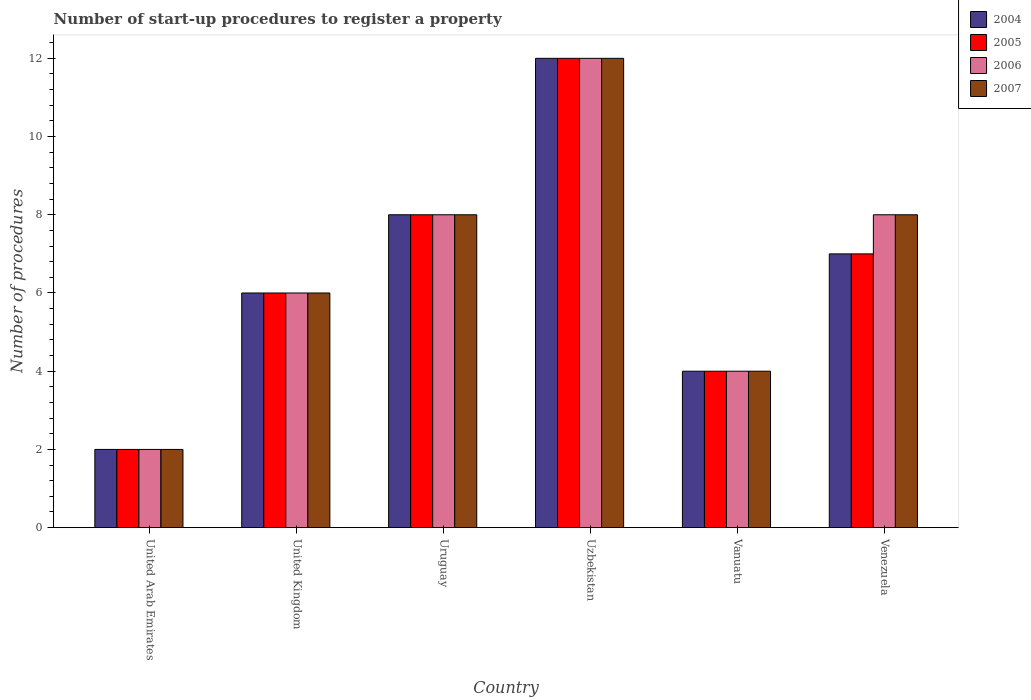How many different coloured bars are there?
Your answer should be compact. 4. Are the number of bars per tick equal to the number of legend labels?
Offer a terse response. Yes. Are the number of bars on each tick of the X-axis equal?
Ensure brevity in your answer.  Yes. What is the label of the 3rd group of bars from the left?
Offer a terse response. Uruguay. In how many cases, is the number of bars for a given country not equal to the number of legend labels?
Make the answer very short. 0. In which country was the number of procedures required to register a property in 2006 maximum?
Offer a terse response. Uzbekistan. In which country was the number of procedures required to register a property in 2006 minimum?
Ensure brevity in your answer.  United Arab Emirates. What is the difference between the number of procedures required to register a property in 2007 in Uzbekistan and that in Vanuatu?
Offer a terse response. 8. Is the number of procedures required to register a property in 2007 in United Arab Emirates less than that in Uzbekistan?
Your response must be concise. Yes. What is the difference between the highest and the second highest number of procedures required to register a property in 2007?
Give a very brief answer. -4. What is the difference between the highest and the lowest number of procedures required to register a property in 2004?
Provide a succinct answer. 10. Is it the case that in every country, the sum of the number of procedures required to register a property in 2005 and number of procedures required to register a property in 2007 is greater than the sum of number of procedures required to register a property in 2004 and number of procedures required to register a property in 2006?
Ensure brevity in your answer.  No. Is it the case that in every country, the sum of the number of procedures required to register a property in 2007 and number of procedures required to register a property in 2004 is greater than the number of procedures required to register a property in 2006?
Keep it short and to the point. Yes. Are the values on the major ticks of Y-axis written in scientific E-notation?
Keep it short and to the point. No. Does the graph contain grids?
Offer a terse response. No. How many legend labels are there?
Ensure brevity in your answer.  4. How are the legend labels stacked?
Ensure brevity in your answer.  Vertical. What is the title of the graph?
Provide a short and direct response. Number of start-up procedures to register a property. What is the label or title of the X-axis?
Offer a very short reply. Country. What is the label or title of the Y-axis?
Provide a succinct answer. Number of procedures. What is the Number of procedures of 2006 in United Arab Emirates?
Offer a terse response. 2. What is the Number of procedures in 2005 in United Kingdom?
Your response must be concise. 6. What is the Number of procedures in 2004 in Uruguay?
Offer a very short reply. 8. What is the Number of procedures in 2006 in Uruguay?
Your response must be concise. 8. What is the Number of procedures of 2007 in Uruguay?
Make the answer very short. 8. What is the Number of procedures of 2004 in Uzbekistan?
Make the answer very short. 12. What is the Number of procedures in 2005 in Uzbekistan?
Your answer should be very brief. 12. What is the Number of procedures of 2007 in Uzbekistan?
Your answer should be very brief. 12. What is the Number of procedures of 2005 in Vanuatu?
Offer a very short reply. 4. What is the Number of procedures in 2006 in Vanuatu?
Give a very brief answer. 4. What is the Number of procedures in 2007 in Vanuatu?
Provide a succinct answer. 4. What is the Number of procedures in 2004 in Venezuela?
Your answer should be compact. 7. What is the Number of procedures in 2005 in Venezuela?
Provide a succinct answer. 7. Across all countries, what is the maximum Number of procedures of 2004?
Provide a short and direct response. 12. Across all countries, what is the minimum Number of procedures in 2005?
Offer a terse response. 2. Across all countries, what is the minimum Number of procedures in 2006?
Provide a succinct answer. 2. What is the total Number of procedures of 2004 in the graph?
Make the answer very short. 39. What is the total Number of procedures of 2005 in the graph?
Provide a succinct answer. 39. What is the total Number of procedures of 2006 in the graph?
Ensure brevity in your answer.  40. What is the total Number of procedures of 2007 in the graph?
Your answer should be compact. 40. What is the difference between the Number of procedures in 2005 in United Arab Emirates and that in United Kingdom?
Ensure brevity in your answer.  -4. What is the difference between the Number of procedures of 2006 in United Arab Emirates and that in United Kingdom?
Ensure brevity in your answer.  -4. What is the difference between the Number of procedures of 2007 in United Arab Emirates and that in United Kingdom?
Keep it short and to the point. -4. What is the difference between the Number of procedures in 2006 in United Arab Emirates and that in Uruguay?
Give a very brief answer. -6. What is the difference between the Number of procedures of 2007 in United Arab Emirates and that in Uruguay?
Your response must be concise. -6. What is the difference between the Number of procedures in 2005 in United Arab Emirates and that in Uzbekistan?
Offer a terse response. -10. What is the difference between the Number of procedures of 2007 in United Arab Emirates and that in Uzbekistan?
Offer a terse response. -10. What is the difference between the Number of procedures of 2005 in United Arab Emirates and that in Vanuatu?
Ensure brevity in your answer.  -2. What is the difference between the Number of procedures of 2006 in United Arab Emirates and that in Vanuatu?
Ensure brevity in your answer.  -2. What is the difference between the Number of procedures of 2007 in United Arab Emirates and that in Venezuela?
Your answer should be compact. -6. What is the difference between the Number of procedures of 2004 in United Kingdom and that in Uruguay?
Provide a succinct answer. -2. What is the difference between the Number of procedures of 2006 in United Kingdom and that in Uruguay?
Your response must be concise. -2. What is the difference between the Number of procedures in 2004 in United Kingdom and that in Uzbekistan?
Provide a succinct answer. -6. What is the difference between the Number of procedures of 2006 in United Kingdom and that in Uzbekistan?
Your answer should be very brief. -6. What is the difference between the Number of procedures in 2007 in United Kingdom and that in Uzbekistan?
Give a very brief answer. -6. What is the difference between the Number of procedures of 2004 in United Kingdom and that in Vanuatu?
Your response must be concise. 2. What is the difference between the Number of procedures of 2005 in United Kingdom and that in Vanuatu?
Your response must be concise. 2. What is the difference between the Number of procedures in 2006 in United Kingdom and that in Vanuatu?
Provide a short and direct response. 2. What is the difference between the Number of procedures in 2004 in United Kingdom and that in Venezuela?
Provide a succinct answer. -1. What is the difference between the Number of procedures of 2005 in United Kingdom and that in Venezuela?
Offer a very short reply. -1. What is the difference between the Number of procedures of 2004 in Uruguay and that in Uzbekistan?
Give a very brief answer. -4. What is the difference between the Number of procedures in 2005 in Uruguay and that in Uzbekistan?
Provide a succinct answer. -4. What is the difference between the Number of procedures in 2004 in Uruguay and that in Vanuatu?
Ensure brevity in your answer.  4. What is the difference between the Number of procedures in 2007 in Uruguay and that in Vanuatu?
Your answer should be very brief. 4. What is the difference between the Number of procedures in 2004 in Uruguay and that in Venezuela?
Your response must be concise. 1. What is the difference between the Number of procedures of 2007 in Uruguay and that in Venezuela?
Offer a very short reply. 0. What is the difference between the Number of procedures in 2004 in Uzbekistan and that in Vanuatu?
Your answer should be very brief. 8. What is the difference between the Number of procedures in 2006 in Uzbekistan and that in Vanuatu?
Your answer should be compact. 8. What is the difference between the Number of procedures of 2007 in Uzbekistan and that in Vanuatu?
Your response must be concise. 8. What is the difference between the Number of procedures of 2005 in Uzbekistan and that in Venezuela?
Provide a short and direct response. 5. What is the difference between the Number of procedures in 2005 in Vanuatu and that in Venezuela?
Give a very brief answer. -3. What is the difference between the Number of procedures in 2007 in Vanuatu and that in Venezuela?
Give a very brief answer. -4. What is the difference between the Number of procedures in 2004 in United Arab Emirates and the Number of procedures in 2005 in United Kingdom?
Ensure brevity in your answer.  -4. What is the difference between the Number of procedures of 2004 in United Arab Emirates and the Number of procedures of 2006 in United Kingdom?
Give a very brief answer. -4. What is the difference between the Number of procedures of 2005 in United Arab Emirates and the Number of procedures of 2007 in United Kingdom?
Make the answer very short. -4. What is the difference between the Number of procedures of 2006 in United Arab Emirates and the Number of procedures of 2007 in United Kingdom?
Provide a short and direct response. -4. What is the difference between the Number of procedures of 2004 in United Arab Emirates and the Number of procedures of 2005 in Uruguay?
Make the answer very short. -6. What is the difference between the Number of procedures in 2004 in United Arab Emirates and the Number of procedures in 2006 in Uruguay?
Your response must be concise. -6. What is the difference between the Number of procedures of 2005 in United Arab Emirates and the Number of procedures of 2006 in Uruguay?
Make the answer very short. -6. What is the difference between the Number of procedures of 2005 in United Arab Emirates and the Number of procedures of 2007 in Uruguay?
Provide a short and direct response. -6. What is the difference between the Number of procedures of 2006 in United Arab Emirates and the Number of procedures of 2007 in Uruguay?
Offer a terse response. -6. What is the difference between the Number of procedures of 2004 in United Arab Emirates and the Number of procedures of 2006 in Uzbekistan?
Keep it short and to the point. -10. What is the difference between the Number of procedures in 2004 in United Arab Emirates and the Number of procedures in 2007 in Uzbekistan?
Your answer should be compact. -10. What is the difference between the Number of procedures in 2005 in United Arab Emirates and the Number of procedures in 2006 in Uzbekistan?
Ensure brevity in your answer.  -10. What is the difference between the Number of procedures of 2005 in United Arab Emirates and the Number of procedures of 2007 in Uzbekistan?
Offer a very short reply. -10. What is the difference between the Number of procedures of 2004 in United Arab Emirates and the Number of procedures of 2005 in Vanuatu?
Ensure brevity in your answer.  -2. What is the difference between the Number of procedures of 2004 in United Arab Emirates and the Number of procedures of 2006 in Vanuatu?
Keep it short and to the point. -2. What is the difference between the Number of procedures in 2004 in United Arab Emirates and the Number of procedures in 2007 in Vanuatu?
Offer a very short reply. -2. What is the difference between the Number of procedures in 2005 in United Arab Emirates and the Number of procedures in 2007 in Vanuatu?
Make the answer very short. -2. What is the difference between the Number of procedures in 2005 in United Arab Emirates and the Number of procedures in 2007 in Venezuela?
Keep it short and to the point. -6. What is the difference between the Number of procedures in 2006 in United Arab Emirates and the Number of procedures in 2007 in Venezuela?
Your response must be concise. -6. What is the difference between the Number of procedures of 2004 in United Kingdom and the Number of procedures of 2005 in Uruguay?
Make the answer very short. -2. What is the difference between the Number of procedures of 2004 in United Kingdom and the Number of procedures of 2005 in Uzbekistan?
Your answer should be very brief. -6. What is the difference between the Number of procedures of 2004 in United Kingdom and the Number of procedures of 2006 in Uzbekistan?
Your answer should be compact. -6. What is the difference between the Number of procedures of 2005 in United Kingdom and the Number of procedures of 2007 in Uzbekistan?
Offer a terse response. -6. What is the difference between the Number of procedures in 2006 in United Kingdom and the Number of procedures in 2007 in Uzbekistan?
Provide a succinct answer. -6. What is the difference between the Number of procedures in 2004 in United Kingdom and the Number of procedures in 2005 in Vanuatu?
Keep it short and to the point. 2. What is the difference between the Number of procedures of 2004 in United Kingdom and the Number of procedures of 2007 in Vanuatu?
Give a very brief answer. 2. What is the difference between the Number of procedures in 2004 in United Kingdom and the Number of procedures in 2007 in Venezuela?
Your response must be concise. -2. What is the difference between the Number of procedures in 2005 in United Kingdom and the Number of procedures in 2006 in Venezuela?
Provide a short and direct response. -2. What is the difference between the Number of procedures in 2005 in United Kingdom and the Number of procedures in 2007 in Venezuela?
Give a very brief answer. -2. What is the difference between the Number of procedures in 2004 in Uruguay and the Number of procedures in 2006 in Uzbekistan?
Your answer should be compact. -4. What is the difference between the Number of procedures in 2004 in Uruguay and the Number of procedures in 2007 in Uzbekistan?
Your answer should be very brief. -4. What is the difference between the Number of procedures of 2005 in Uruguay and the Number of procedures of 2007 in Uzbekistan?
Your answer should be very brief. -4. What is the difference between the Number of procedures in 2004 in Uruguay and the Number of procedures in 2005 in Vanuatu?
Keep it short and to the point. 4. What is the difference between the Number of procedures in 2004 in Uruguay and the Number of procedures in 2007 in Vanuatu?
Keep it short and to the point. 4. What is the difference between the Number of procedures in 2006 in Uruguay and the Number of procedures in 2007 in Vanuatu?
Keep it short and to the point. 4. What is the difference between the Number of procedures in 2004 in Uruguay and the Number of procedures in 2005 in Venezuela?
Give a very brief answer. 1. What is the difference between the Number of procedures of 2004 in Uruguay and the Number of procedures of 2007 in Venezuela?
Your response must be concise. 0. What is the difference between the Number of procedures in 2005 in Uruguay and the Number of procedures in 2007 in Venezuela?
Offer a very short reply. 0. What is the difference between the Number of procedures of 2004 in Vanuatu and the Number of procedures of 2005 in Venezuela?
Your response must be concise. -3. What is the difference between the Number of procedures of 2004 in Vanuatu and the Number of procedures of 2006 in Venezuela?
Your response must be concise. -4. What is the difference between the Number of procedures of 2005 in Vanuatu and the Number of procedures of 2007 in Venezuela?
Provide a succinct answer. -4. What is the average Number of procedures of 2005 per country?
Ensure brevity in your answer.  6.5. What is the difference between the Number of procedures of 2004 and Number of procedures of 2005 in United Arab Emirates?
Your answer should be very brief. 0. What is the difference between the Number of procedures in 2004 and Number of procedures in 2007 in United Arab Emirates?
Give a very brief answer. 0. What is the difference between the Number of procedures of 2005 and Number of procedures of 2006 in United Arab Emirates?
Make the answer very short. 0. What is the difference between the Number of procedures in 2005 and Number of procedures in 2007 in United Arab Emirates?
Keep it short and to the point. 0. What is the difference between the Number of procedures in 2004 and Number of procedures in 2005 in United Kingdom?
Your response must be concise. 0. What is the difference between the Number of procedures of 2004 and Number of procedures of 2007 in United Kingdom?
Provide a succinct answer. 0. What is the difference between the Number of procedures of 2004 and Number of procedures of 2007 in Uruguay?
Ensure brevity in your answer.  0. What is the difference between the Number of procedures in 2005 and Number of procedures in 2006 in Uruguay?
Make the answer very short. 0. What is the difference between the Number of procedures of 2004 and Number of procedures of 2005 in Uzbekistan?
Provide a succinct answer. 0. What is the difference between the Number of procedures in 2004 and Number of procedures in 2006 in Uzbekistan?
Give a very brief answer. 0. What is the difference between the Number of procedures of 2005 and Number of procedures of 2007 in Uzbekistan?
Your answer should be very brief. 0. What is the difference between the Number of procedures in 2006 and Number of procedures in 2007 in Uzbekistan?
Keep it short and to the point. 0. What is the difference between the Number of procedures of 2005 and Number of procedures of 2006 in Vanuatu?
Ensure brevity in your answer.  0. What is the difference between the Number of procedures of 2005 and Number of procedures of 2007 in Vanuatu?
Your answer should be very brief. 0. What is the difference between the Number of procedures of 2006 and Number of procedures of 2007 in Vanuatu?
Provide a short and direct response. 0. What is the difference between the Number of procedures of 2004 and Number of procedures of 2006 in Venezuela?
Your response must be concise. -1. What is the difference between the Number of procedures in 2005 and Number of procedures in 2006 in Venezuela?
Make the answer very short. -1. What is the difference between the Number of procedures in 2006 and Number of procedures in 2007 in Venezuela?
Provide a succinct answer. 0. What is the ratio of the Number of procedures in 2005 in United Arab Emirates to that in Uruguay?
Your answer should be compact. 0.25. What is the ratio of the Number of procedures of 2004 in United Arab Emirates to that in Vanuatu?
Offer a terse response. 0.5. What is the ratio of the Number of procedures of 2005 in United Arab Emirates to that in Vanuatu?
Offer a very short reply. 0.5. What is the ratio of the Number of procedures of 2006 in United Arab Emirates to that in Vanuatu?
Provide a short and direct response. 0.5. What is the ratio of the Number of procedures in 2007 in United Arab Emirates to that in Vanuatu?
Ensure brevity in your answer.  0.5. What is the ratio of the Number of procedures in 2004 in United Arab Emirates to that in Venezuela?
Your answer should be very brief. 0.29. What is the ratio of the Number of procedures in 2005 in United Arab Emirates to that in Venezuela?
Provide a succinct answer. 0.29. What is the ratio of the Number of procedures in 2006 in United Arab Emirates to that in Venezuela?
Your answer should be compact. 0.25. What is the ratio of the Number of procedures of 2007 in United Arab Emirates to that in Venezuela?
Provide a short and direct response. 0.25. What is the ratio of the Number of procedures of 2005 in United Kingdom to that in Uruguay?
Offer a very short reply. 0.75. What is the ratio of the Number of procedures of 2007 in United Kingdom to that in Uruguay?
Your response must be concise. 0.75. What is the ratio of the Number of procedures of 2005 in United Kingdom to that in Uzbekistan?
Give a very brief answer. 0.5. What is the ratio of the Number of procedures in 2006 in United Kingdom to that in Uzbekistan?
Give a very brief answer. 0.5. What is the ratio of the Number of procedures in 2005 in United Kingdom to that in Vanuatu?
Offer a very short reply. 1.5. What is the ratio of the Number of procedures in 2006 in United Kingdom to that in Vanuatu?
Make the answer very short. 1.5. What is the ratio of the Number of procedures of 2004 in United Kingdom to that in Venezuela?
Your response must be concise. 0.86. What is the ratio of the Number of procedures of 2005 in United Kingdom to that in Venezuela?
Ensure brevity in your answer.  0.86. What is the ratio of the Number of procedures of 2007 in United Kingdom to that in Venezuela?
Offer a very short reply. 0.75. What is the ratio of the Number of procedures in 2004 in Uruguay to that in Uzbekistan?
Offer a very short reply. 0.67. What is the ratio of the Number of procedures of 2005 in Uruguay to that in Uzbekistan?
Offer a terse response. 0.67. What is the ratio of the Number of procedures in 2006 in Uruguay to that in Uzbekistan?
Provide a short and direct response. 0.67. What is the ratio of the Number of procedures of 2007 in Uruguay to that in Uzbekistan?
Ensure brevity in your answer.  0.67. What is the ratio of the Number of procedures of 2005 in Uruguay to that in Vanuatu?
Offer a very short reply. 2. What is the ratio of the Number of procedures of 2006 in Uruguay to that in Vanuatu?
Offer a very short reply. 2. What is the ratio of the Number of procedures in 2007 in Uruguay to that in Vanuatu?
Ensure brevity in your answer.  2. What is the ratio of the Number of procedures of 2005 in Uruguay to that in Venezuela?
Provide a succinct answer. 1.14. What is the ratio of the Number of procedures of 2007 in Uruguay to that in Venezuela?
Make the answer very short. 1. What is the ratio of the Number of procedures in 2004 in Uzbekistan to that in Vanuatu?
Offer a very short reply. 3. What is the ratio of the Number of procedures of 2005 in Uzbekistan to that in Vanuatu?
Offer a very short reply. 3. What is the ratio of the Number of procedures in 2006 in Uzbekistan to that in Vanuatu?
Offer a very short reply. 3. What is the ratio of the Number of procedures in 2007 in Uzbekistan to that in Vanuatu?
Your answer should be compact. 3. What is the ratio of the Number of procedures in 2004 in Uzbekistan to that in Venezuela?
Your response must be concise. 1.71. What is the ratio of the Number of procedures in 2005 in Uzbekistan to that in Venezuela?
Give a very brief answer. 1.71. What is the ratio of the Number of procedures of 2005 in Vanuatu to that in Venezuela?
Offer a terse response. 0.57. What is the ratio of the Number of procedures in 2006 in Vanuatu to that in Venezuela?
Your answer should be very brief. 0.5. What is the ratio of the Number of procedures of 2007 in Vanuatu to that in Venezuela?
Offer a terse response. 0.5. What is the difference between the highest and the second highest Number of procedures in 2004?
Offer a very short reply. 4. What is the difference between the highest and the second highest Number of procedures in 2005?
Your response must be concise. 4. What is the difference between the highest and the second highest Number of procedures in 2006?
Keep it short and to the point. 4. What is the difference between the highest and the lowest Number of procedures in 2006?
Keep it short and to the point. 10. What is the difference between the highest and the lowest Number of procedures of 2007?
Offer a very short reply. 10. 